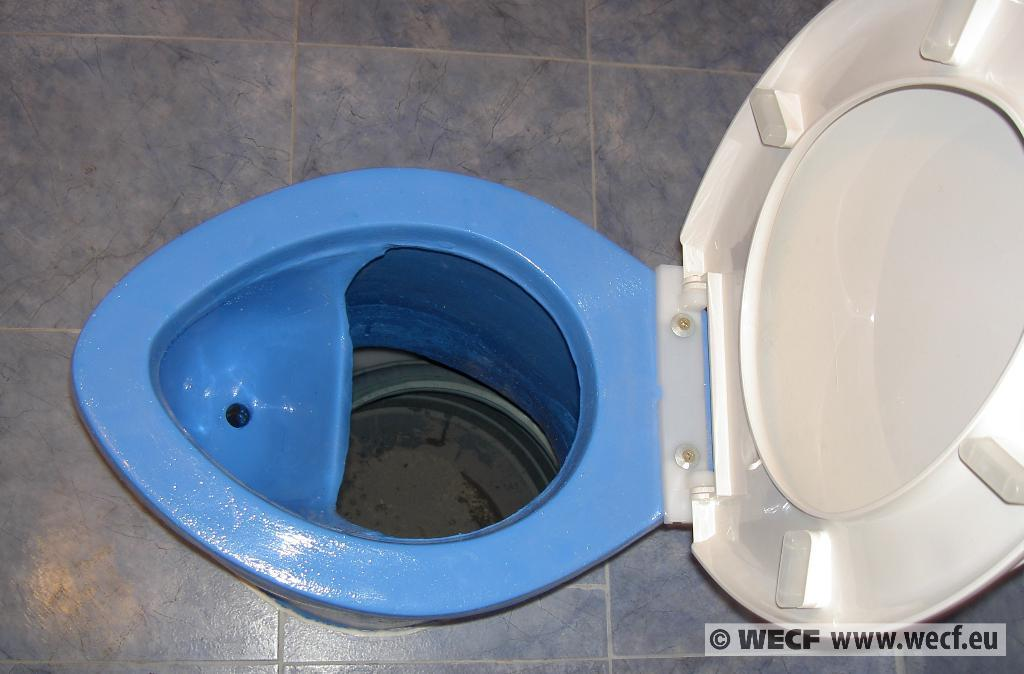What object is the main focus of the image? The main focus of the image is a toilet seat. What feature does the toilet seat have? The toilet seat has a lid. What can be seen in the background of the image? The background of the image includes the floor. Is there any additional information or marking on the image? Yes, there is a watermark at the bottom of the image. What type of gold spring can be seen attached to the toilet seat in the image? There is no gold spring or any spring attached to the toilet seat in the image. 